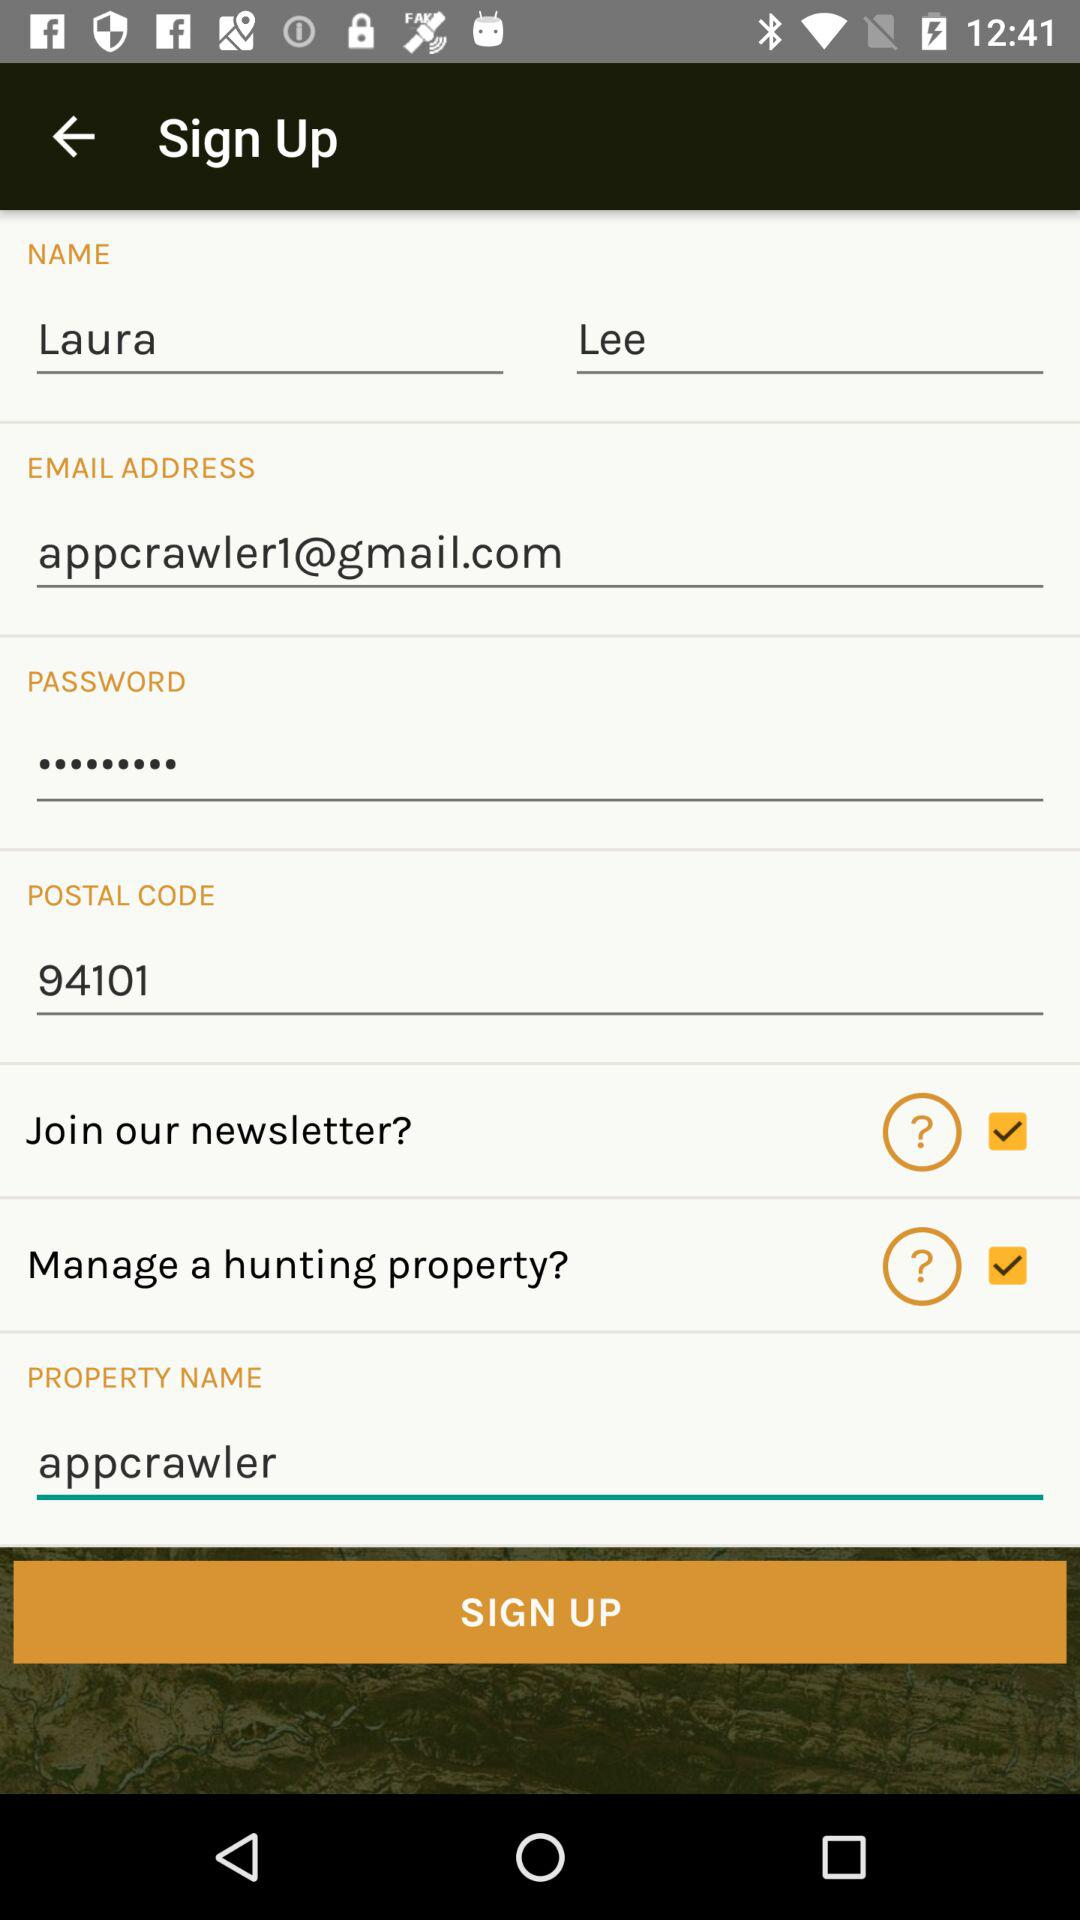What is the last name? The last name is Lee. 